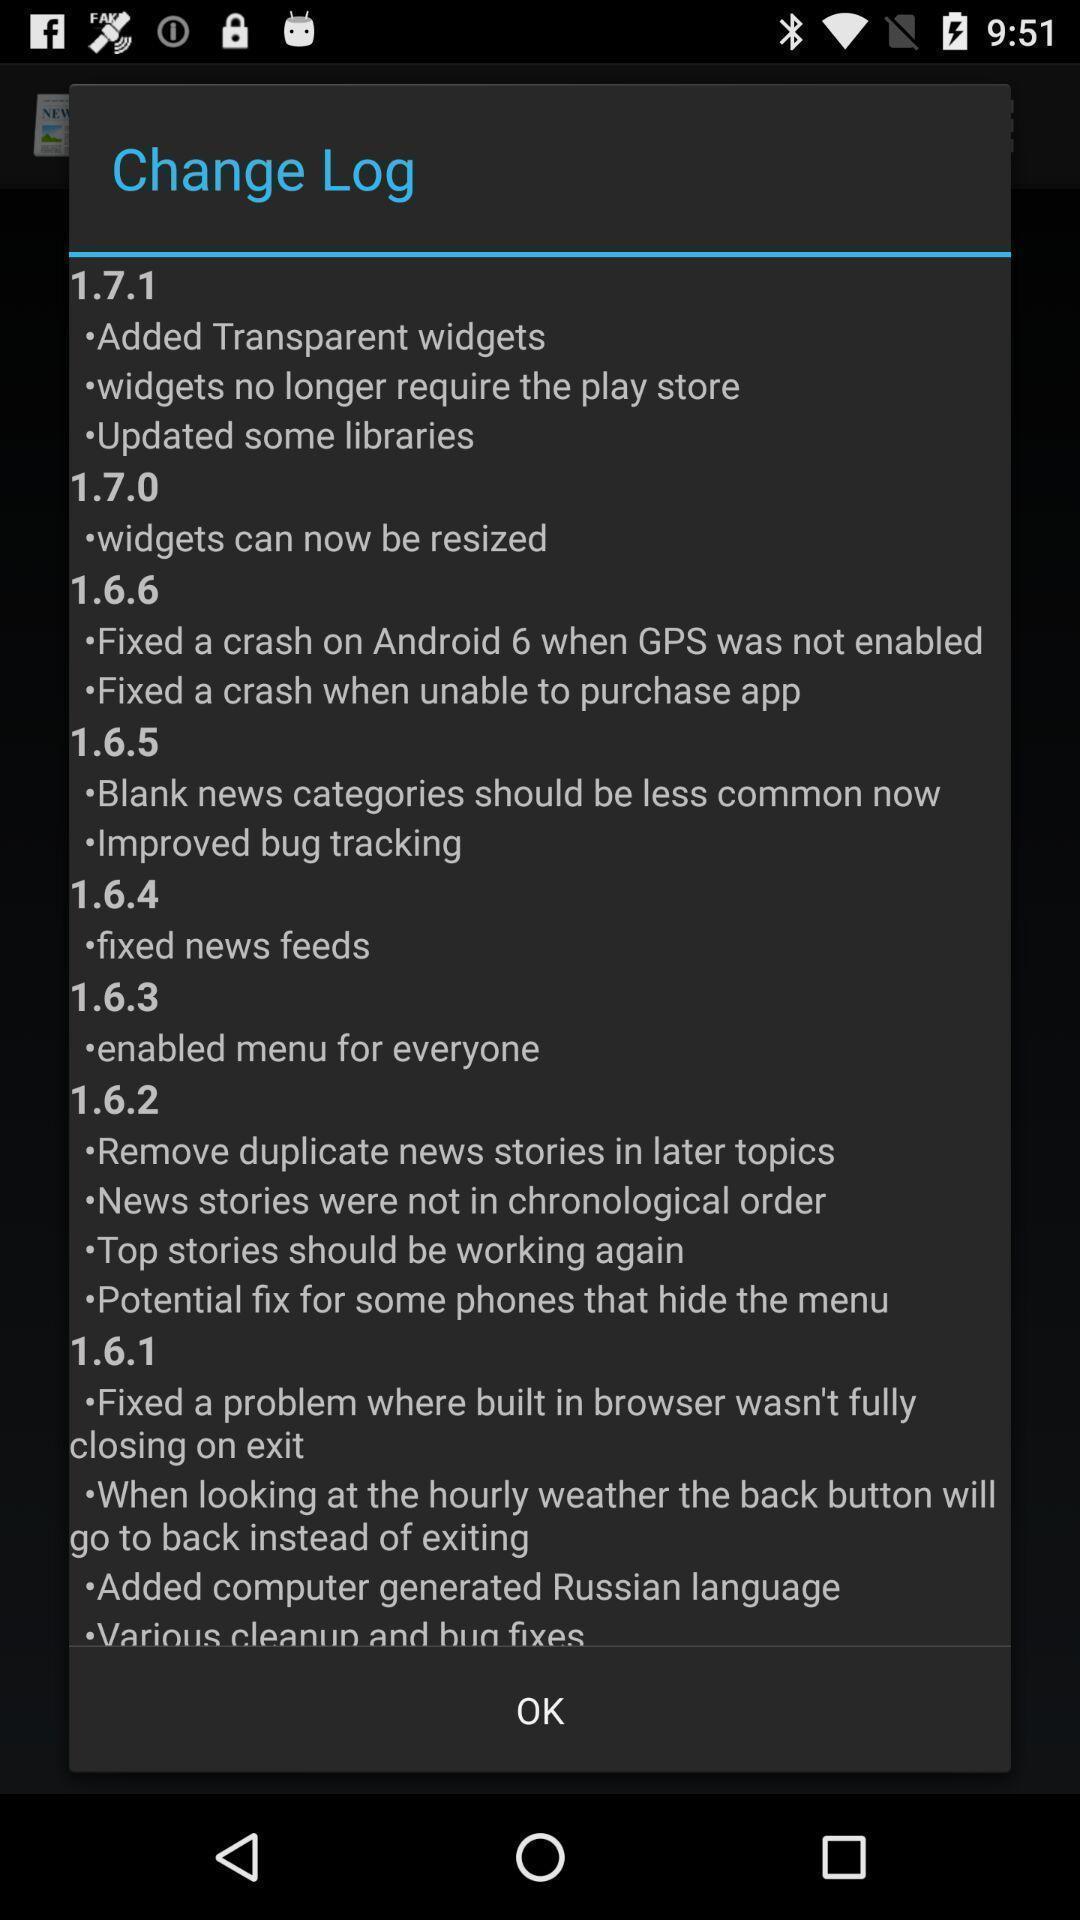Describe the visual elements of this screenshot. Screen showing information about the change log. 